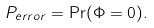<formula> <loc_0><loc_0><loc_500><loc_500>P _ { e r r o r } = \Pr ( \Phi = 0 ) .</formula> 